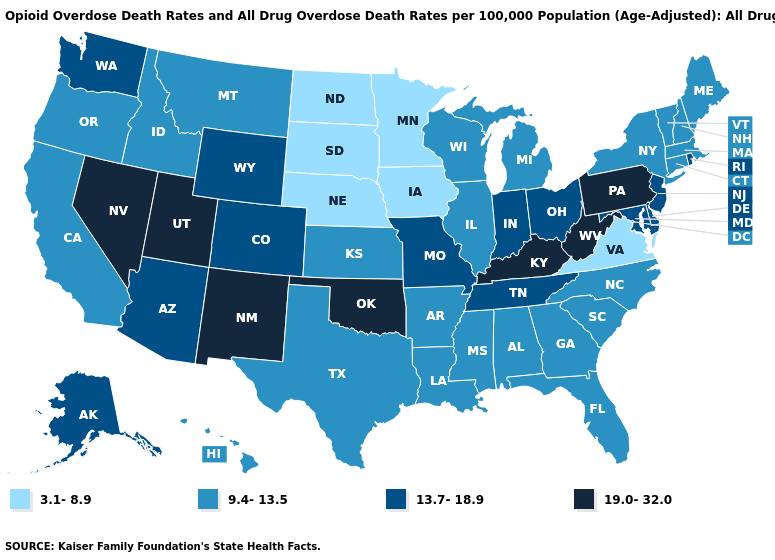Name the states that have a value in the range 3.1-8.9?
Write a very short answer. Iowa, Minnesota, Nebraska, North Dakota, South Dakota, Virginia. Name the states that have a value in the range 19.0-32.0?
Concise answer only. Kentucky, Nevada, New Mexico, Oklahoma, Pennsylvania, Utah, West Virginia. Name the states that have a value in the range 13.7-18.9?
Concise answer only. Alaska, Arizona, Colorado, Delaware, Indiana, Maryland, Missouri, New Jersey, Ohio, Rhode Island, Tennessee, Washington, Wyoming. Which states have the lowest value in the USA?
Quick response, please. Iowa, Minnesota, Nebraska, North Dakota, South Dakota, Virginia. Name the states that have a value in the range 13.7-18.9?
Concise answer only. Alaska, Arizona, Colorado, Delaware, Indiana, Maryland, Missouri, New Jersey, Ohio, Rhode Island, Tennessee, Washington, Wyoming. Does South Dakota have the same value as Missouri?
Concise answer only. No. Does New York have a higher value than Kentucky?
Short answer required. No. Does Kentucky have the lowest value in the South?
Keep it brief. No. Name the states that have a value in the range 3.1-8.9?
Write a very short answer. Iowa, Minnesota, Nebraska, North Dakota, South Dakota, Virginia. What is the lowest value in states that border New Hampshire?
Keep it brief. 9.4-13.5. Name the states that have a value in the range 3.1-8.9?
Quick response, please. Iowa, Minnesota, Nebraska, North Dakota, South Dakota, Virginia. What is the value of Connecticut?
Give a very brief answer. 9.4-13.5. Which states have the lowest value in the USA?
Be succinct. Iowa, Minnesota, Nebraska, North Dakota, South Dakota, Virginia. Among the states that border Virginia , which have the lowest value?
Quick response, please. North Carolina. What is the highest value in states that border Alabama?
Write a very short answer. 13.7-18.9. 